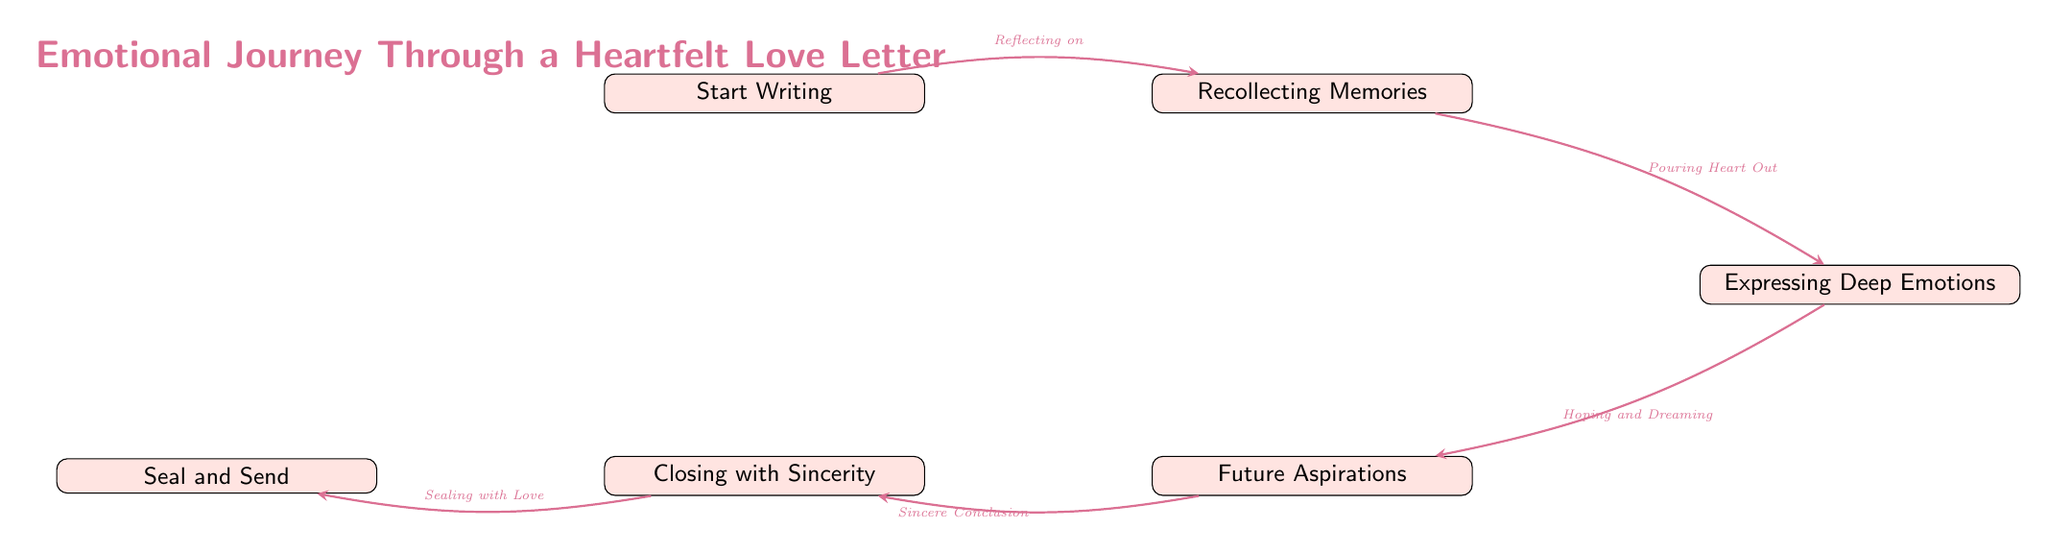What is the first node in the diagram? The diagram's starting point is the "Start Writing" node, which initiates the emotional journey described in the flow chart.
Answer: Start Writing How many nodes are there in total? The diagram contains six distinct nodes that represent different steps in the emotional journey through a love letter.
Answer: 6 What is the last node before sealing the letter? The node immediately preceding the "Seal and Send" step is "Closing with Sincerity," which emphasizes the commitment before sending the letter.
Answer: Closing with Sincerity What does the edge from "Recollecting Memories" to "Expressing Deep Emotions" represent? The connection labeled "Pouring Heart Out" signifies a transition where memories evoke feelings that then lead to expressing those heartfelt emotions.
Answer: Pouring Heart Out Which node discusses aspirations for the future? The "Future Aspirations" node focuses on envisioning the dreams and plans that the couple shares, indicating hope for what lies ahead.
Answer: Future Aspirations What is the relationship between "Expressing Deep Emotions" and "Future Aspirations"? The link labeled "Hoping and Dreaming" indicates that after expressing feelings, the next step involves contemplating the future together.
Answer: Hoping and Dreaming How does the journey conclude in the diagram? The final step in the journey is "Seal and Send," marking the end of the emotional process where the letter is completed and sent.
Answer: Seal and Send What flows into the "Closing with Sincerity" node? The "Future Aspirations" node leads into this closing segment, underscoring the heartfelt conclusion after discussing future dreams.
Answer: Future Aspirations What node directly follows "Start Writing"? The very next node in the flow chart after starting to write is "Recollecting Memories," which demonstrates where the emotional journey begins.
Answer: Recollecting Memories 